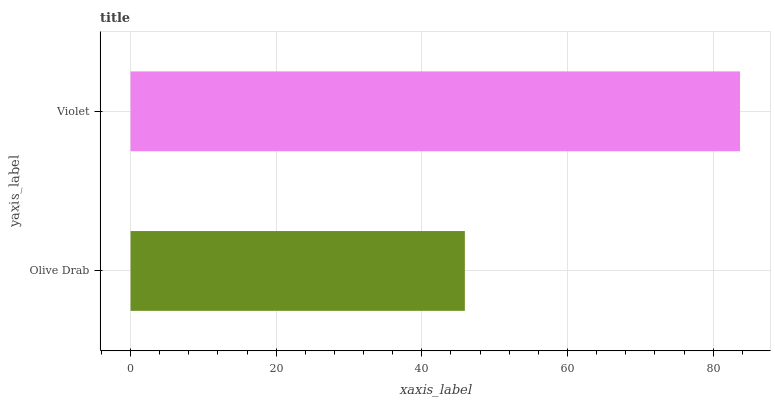Is Olive Drab the minimum?
Answer yes or no. Yes. Is Violet the maximum?
Answer yes or no. Yes. Is Violet the minimum?
Answer yes or no. No. Is Violet greater than Olive Drab?
Answer yes or no. Yes. Is Olive Drab less than Violet?
Answer yes or no. Yes. Is Olive Drab greater than Violet?
Answer yes or no. No. Is Violet less than Olive Drab?
Answer yes or no. No. Is Violet the high median?
Answer yes or no. Yes. Is Olive Drab the low median?
Answer yes or no. Yes. Is Olive Drab the high median?
Answer yes or no. No. Is Violet the low median?
Answer yes or no. No. 